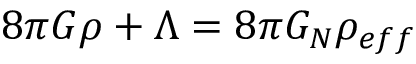Convert formula to latex. <formula><loc_0><loc_0><loc_500><loc_500>8 \pi G \rho + \Lambda = 8 \pi G _ { N } \rho _ { e f f }</formula> 